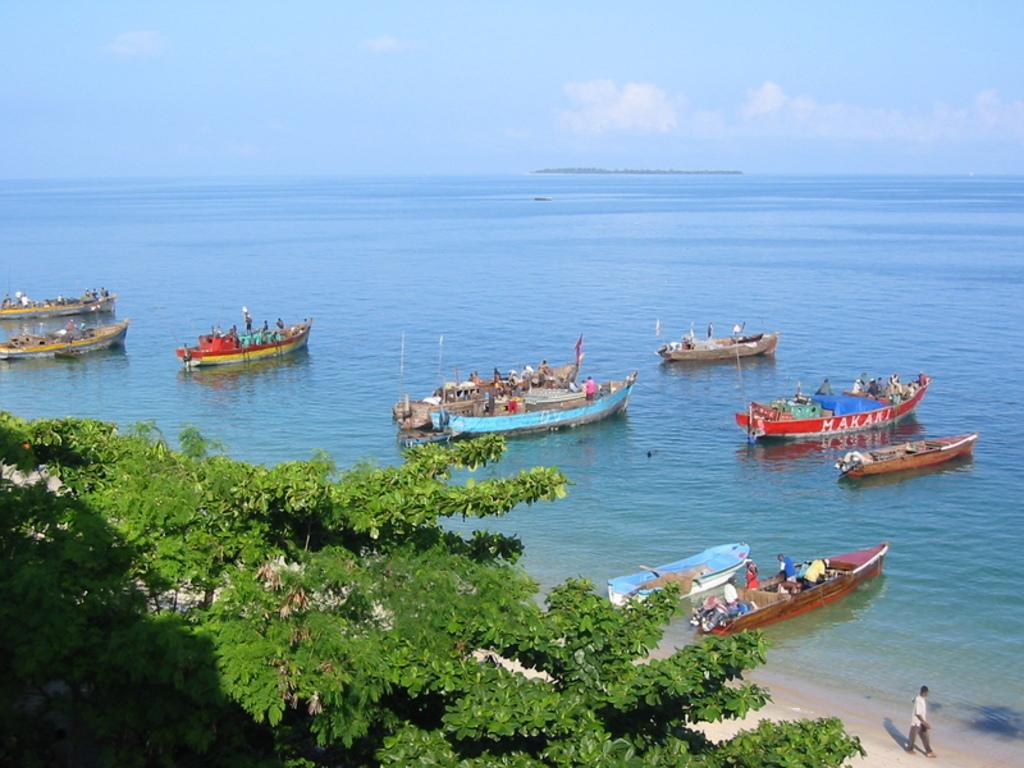What is located in the center of the image? There are trees in the center of the image. What can be seen in the water in the image? There are boats in the image. What is the primary element visible in the image? Water is visible in the image. What are the flags used for in the image? The flags are present in the image, but their purpose is not specified. How many people are in the boat? There are people in the boat. What is visible in the background of the image? The sky, clouds, and water are visible in the background of the image. What type of government is depicted in the image? There is no indication of a government in the image; it features trees, boats, water, flags, and people in a boat. What is the purpose of the basket in the image? There is no basket present in the image. 